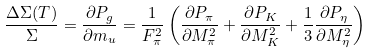Convert formula to latex. <formula><loc_0><loc_0><loc_500><loc_500>\frac { \Delta \Sigma ( T ) } { \Sigma } = \frac { \partial P _ { g } } { \partial m _ { u } } = \frac { 1 } { F _ { \pi } ^ { 2 } } \left ( \frac { \partial P _ { \pi } } { \partial M _ { \pi } ^ { 2 } } + \frac { \partial P _ { K } } { \partial M _ { K } ^ { 2 } } + \frac { 1 } { 3 } \frac { \partial P _ { \eta } } { \partial M _ { \eta } ^ { 2 } } \right )</formula> 